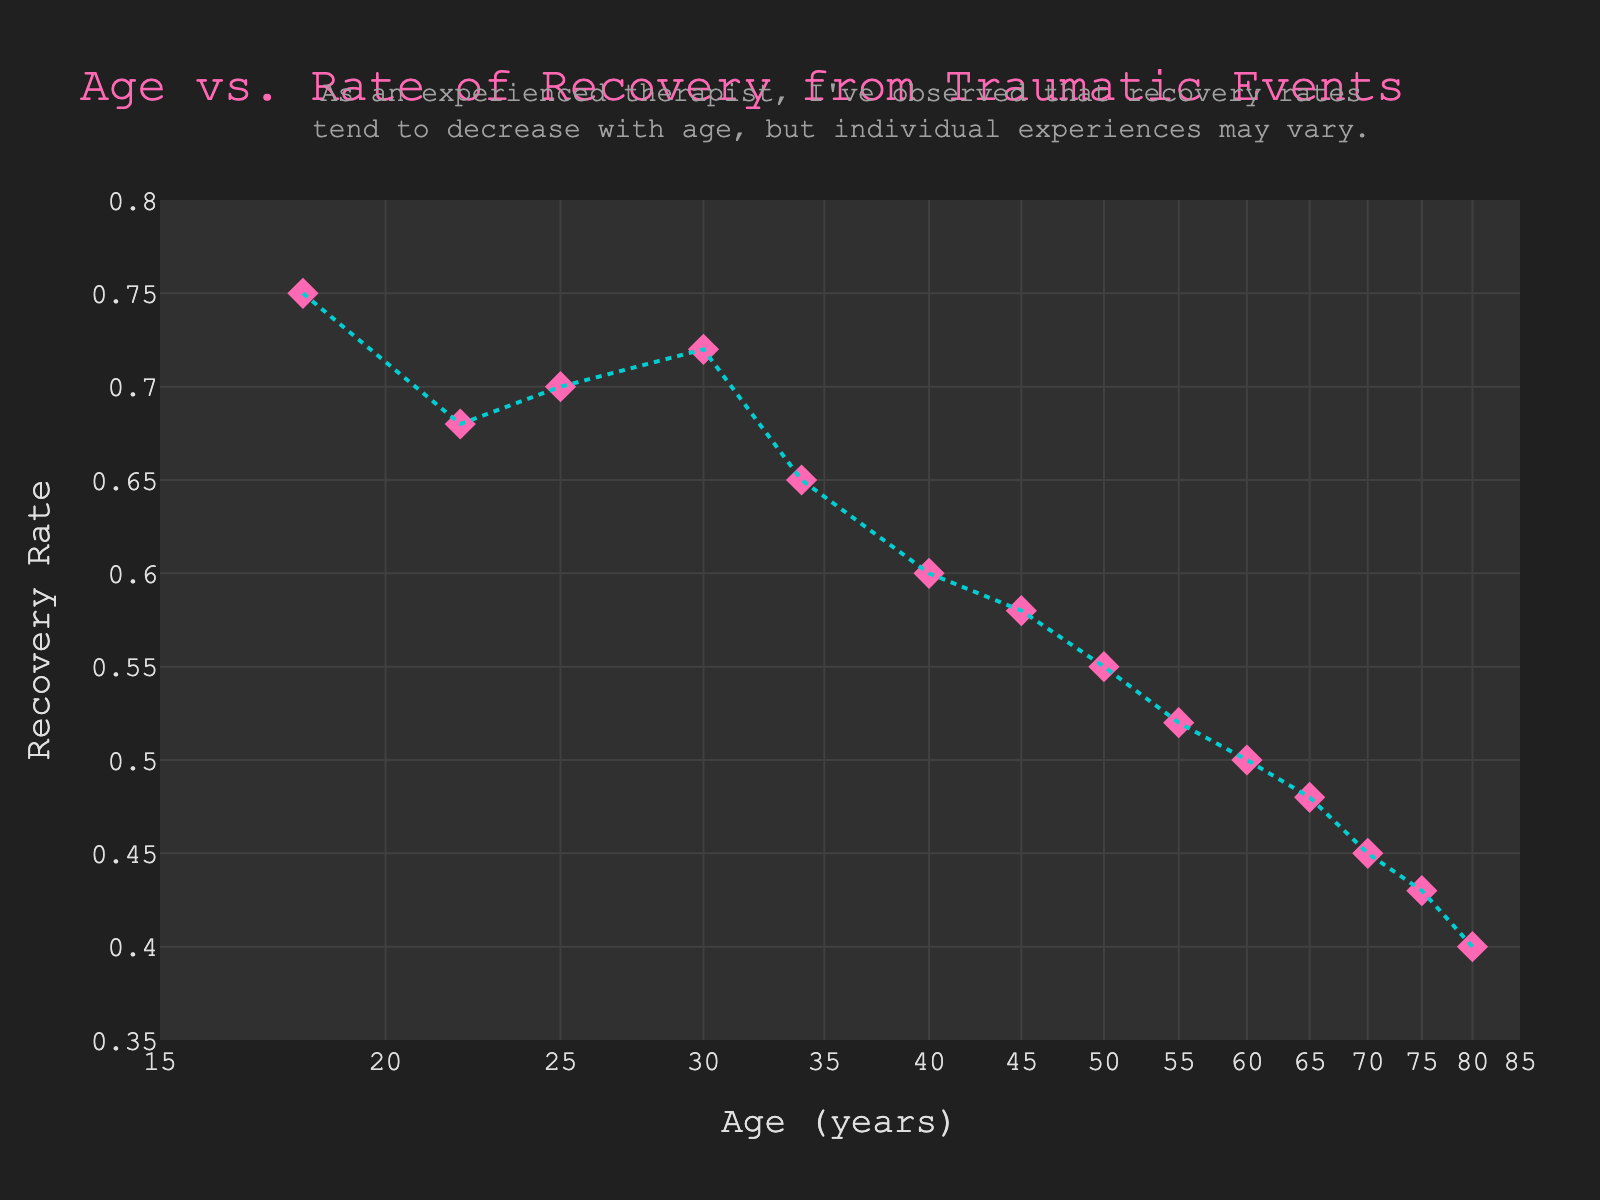What's the title of the chart? The title is displayed at the top of the figure and provides an overview of what the chart is about. The title for this chart is "Age vs. Rate of Recovery from Traumatic Events".
Answer: Age vs. Rate of Recovery from Traumatic Events What does the x-axis represent? The x-axis represents age, measured in years, and is plotted on a logarithmic scale.
Answer: Age (years) How many data points are plotted on the chart? By counting the number of markers (points) on the scatter plot, we can determine that there are 14 data points.
Answer: 14 What marker shape is used in the scatter plot? The shape of the marker in the scatter plot is a diamond. This is indicated visually by the shape of the plotted points.
Answer: Diamond What is the recovery rate for a 50-year-old patient? From the scatter plot, locate the age 50 on the x-axis and find the corresponding y-value. The recovery rate for a 50-year-old is 0.55.
Answer: 0.55 What's the range of the y-axis? The y-axis ranges from 0.35 to 0.8 as indicated by the axis limits on the plot.
Answer: 0.35 to 0.8 Compare the recovery rates of patients aged 25 and 70. Which age has a higher rate of recovery? Locate the points for ages 25 and 70 on the x-axis, then compare the corresponding y-values. Age 25 has a recovery rate of 0.70 and age 70 has 0.45. Therefore, 25-year-olds have a higher recovery rate.
Answer: Age 25 What is the visual color of the markers? The color of the markers is displayed visually in pink on the scatter plot.
Answer: Pink Based on the trend line, does the recovery rate increase or decrease with age? The trend line in the scatter plot, which is dashed blue, shows a decreasing pattern from left to right, indicating that the recovery rate decreases with age.
Answer: Decrease Is there any annotation included in the chart and what does it say? Yes, there is an annotation above the chart that mentions "As an experienced therapist, I've observed that recovery rates tend to decrease with age, but individual experiences may vary."
Answer: Recovery rates tend to decrease with age, but individual experiences may vary 